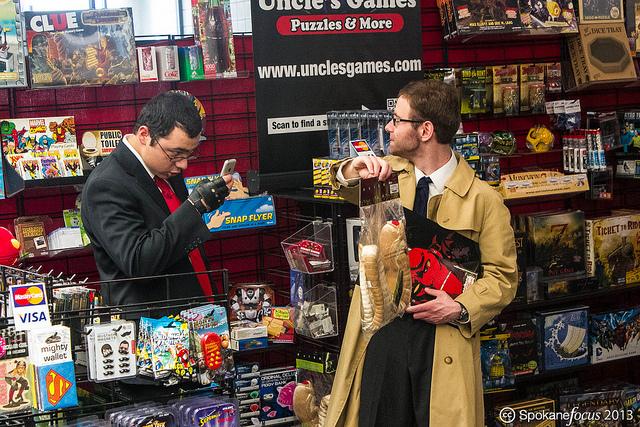What type of store is this?
Be succinct. Game. What credit card types are accepted?
Answer briefly. Mastercard and visa. Are they both wearing glasses?
Short answer required. Yes. 